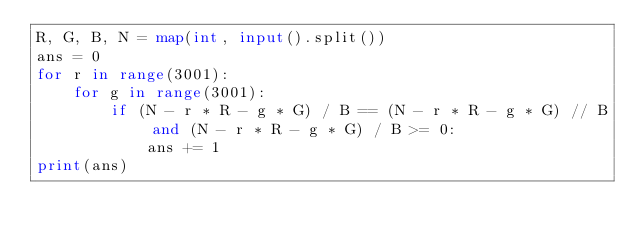Convert code to text. <code><loc_0><loc_0><loc_500><loc_500><_Python_>R, G, B, N = map(int, input().split())
ans = 0
for r in range(3001):
    for g in range(3001):
        if (N - r * R - g * G) / B == (N - r * R - g * G) // B and (N - r * R - g * G) / B >= 0:
            ans += 1
print(ans)</code> 